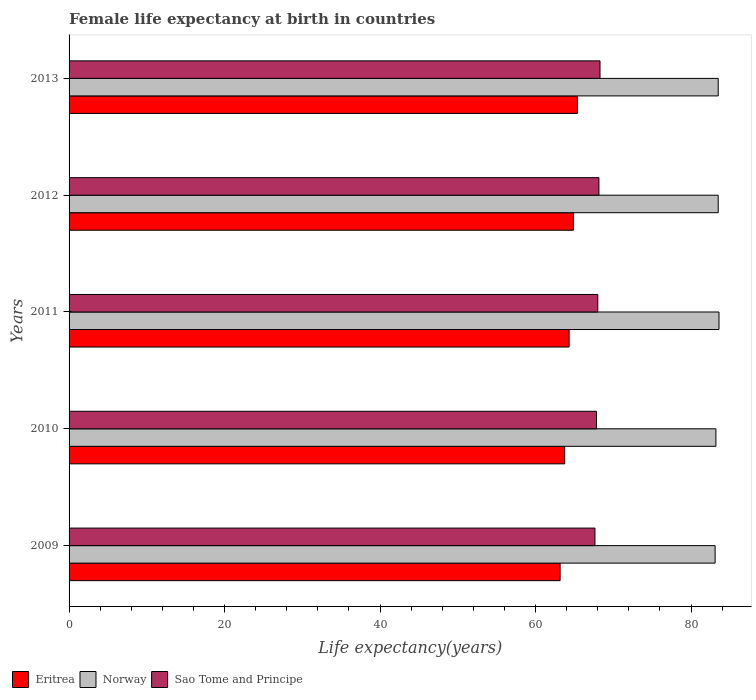How many groups of bars are there?
Offer a very short reply. 5. In how many cases, is the number of bars for a given year not equal to the number of legend labels?
Your response must be concise. 0. What is the female life expectancy at birth in Norway in 2012?
Give a very brief answer. 83.5. Across all years, what is the maximum female life expectancy at birth in Eritrea?
Offer a terse response. 65.39. Across all years, what is the minimum female life expectancy at birth in Sao Tome and Principe?
Your answer should be compact. 67.64. In which year was the female life expectancy at birth in Eritrea minimum?
Your answer should be very brief. 2009. What is the total female life expectancy at birth in Norway in the graph?
Give a very brief answer. 416.9. What is the difference between the female life expectancy at birth in Norway in 2009 and that in 2010?
Your answer should be very brief. -0.1. What is the difference between the female life expectancy at birth in Eritrea in 2011 and the female life expectancy at birth in Sao Tome and Principe in 2013?
Make the answer very short. -3.97. What is the average female life expectancy at birth in Eritrea per year?
Offer a very short reply. 64.3. In the year 2010, what is the difference between the female life expectancy at birth in Sao Tome and Principe and female life expectancy at birth in Norway?
Offer a terse response. -15.36. What is the ratio of the female life expectancy at birth in Norway in 2010 to that in 2012?
Provide a succinct answer. 1. Is the female life expectancy at birth in Eritrea in 2009 less than that in 2011?
Your response must be concise. Yes. Is the difference between the female life expectancy at birth in Sao Tome and Principe in 2010 and 2011 greater than the difference between the female life expectancy at birth in Norway in 2010 and 2011?
Give a very brief answer. Yes. What is the difference between the highest and the second highest female life expectancy at birth in Norway?
Provide a succinct answer. 0.1. What is the difference between the highest and the lowest female life expectancy at birth in Eritrea?
Offer a terse response. 2.23. Is the sum of the female life expectancy at birth in Sao Tome and Principe in 2011 and 2013 greater than the maximum female life expectancy at birth in Eritrea across all years?
Provide a succinct answer. Yes. What does the 3rd bar from the top in 2009 represents?
Provide a short and direct response. Eritrea. What does the 1st bar from the bottom in 2012 represents?
Ensure brevity in your answer.  Eritrea. Is it the case that in every year, the sum of the female life expectancy at birth in Norway and female life expectancy at birth in Sao Tome and Principe is greater than the female life expectancy at birth in Eritrea?
Provide a short and direct response. Yes. Are all the bars in the graph horizontal?
Offer a terse response. Yes. How many years are there in the graph?
Provide a succinct answer. 5. What is the difference between two consecutive major ticks on the X-axis?
Keep it short and to the point. 20. Where does the legend appear in the graph?
Offer a very short reply. Bottom left. How many legend labels are there?
Ensure brevity in your answer.  3. How are the legend labels stacked?
Provide a short and direct response. Horizontal. What is the title of the graph?
Provide a short and direct response. Female life expectancy at birth in countries. What is the label or title of the X-axis?
Keep it short and to the point. Life expectancy(years). What is the label or title of the Y-axis?
Provide a short and direct response. Years. What is the Life expectancy(years) in Eritrea in 2009?
Your response must be concise. 63.16. What is the Life expectancy(years) in Norway in 2009?
Your answer should be very brief. 83.1. What is the Life expectancy(years) in Sao Tome and Principe in 2009?
Your answer should be very brief. 67.64. What is the Life expectancy(years) in Eritrea in 2010?
Provide a short and direct response. 63.75. What is the Life expectancy(years) of Norway in 2010?
Give a very brief answer. 83.2. What is the Life expectancy(years) in Sao Tome and Principe in 2010?
Offer a terse response. 67.84. What is the Life expectancy(years) in Eritrea in 2011?
Your answer should be compact. 64.32. What is the Life expectancy(years) of Norway in 2011?
Your answer should be compact. 83.6. What is the Life expectancy(years) in Sao Tome and Principe in 2011?
Offer a very short reply. 68.01. What is the Life expectancy(years) of Eritrea in 2012?
Make the answer very short. 64.87. What is the Life expectancy(years) of Norway in 2012?
Provide a short and direct response. 83.5. What is the Life expectancy(years) of Sao Tome and Principe in 2012?
Offer a very short reply. 68.15. What is the Life expectancy(years) of Eritrea in 2013?
Make the answer very short. 65.39. What is the Life expectancy(years) in Norway in 2013?
Ensure brevity in your answer.  83.5. What is the Life expectancy(years) in Sao Tome and Principe in 2013?
Keep it short and to the point. 68.3. Across all years, what is the maximum Life expectancy(years) of Eritrea?
Your answer should be very brief. 65.39. Across all years, what is the maximum Life expectancy(years) in Norway?
Your answer should be very brief. 83.6. Across all years, what is the maximum Life expectancy(years) of Sao Tome and Principe?
Your response must be concise. 68.3. Across all years, what is the minimum Life expectancy(years) of Eritrea?
Provide a short and direct response. 63.16. Across all years, what is the minimum Life expectancy(years) in Norway?
Provide a succinct answer. 83.1. Across all years, what is the minimum Life expectancy(years) of Sao Tome and Principe?
Your answer should be compact. 67.64. What is the total Life expectancy(years) in Eritrea in the graph?
Your answer should be very brief. 321.49. What is the total Life expectancy(years) of Norway in the graph?
Keep it short and to the point. 416.9. What is the total Life expectancy(years) of Sao Tome and Principe in the graph?
Make the answer very short. 339.94. What is the difference between the Life expectancy(years) in Eritrea in 2009 and that in 2010?
Provide a short and direct response. -0.59. What is the difference between the Life expectancy(years) of Eritrea in 2009 and that in 2011?
Your answer should be compact. -1.16. What is the difference between the Life expectancy(years) of Sao Tome and Principe in 2009 and that in 2011?
Ensure brevity in your answer.  -0.37. What is the difference between the Life expectancy(years) of Eritrea in 2009 and that in 2012?
Offer a very short reply. -1.71. What is the difference between the Life expectancy(years) of Sao Tome and Principe in 2009 and that in 2012?
Offer a very short reply. -0.51. What is the difference between the Life expectancy(years) in Eritrea in 2009 and that in 2013?
Your answer should be very brief. -2.23. What is the difference between the Life expectancy(years) of Norway in 2009 and that in 2013?
Your answer should be compact. -0.4. What is the difference between the Life expectancy(years) in Sao Tome and Principe in 2009 and that in 2013?
Your answer should be compact. -0.65. What is the difference between the Life expectancy(years) of Eritrea in 2010 and that in 2011?
Offer a terse response. -0.57. What is the difference between the Life expectancy(years) of Norway in 2010 and that in 2011?
Make the answer very short. -0.4. What is the difference between the Life expectancy(years) in Sao Tome and Principe in 2010 and that in 2011?
Ensure brevity in your answer.  -0.17. What is the difference between the Life expectancy(years) of Eritrea in 2010 and that in 2012?
Your answer should be very brief. -1.12. What is the difference between the Life expectancy(years) of Norway in 2010 and that in 2012?
Your answer should be compact. -0.3. What is the difference between the Life expectancy(years) of Sao Tome and Principe in 2010 and that in 2012?
Your response must be concise. -0.31. What is the difference between the Life expectancy(years) in Eritrea in 2010 and that in 2013?
Offer a terse response. -1.64. What is the difference between the Life expectancy(years) of Norway in 2010 and that in 2013?
Your answer should be compact. -0.3. What is the difference between the Life expectancy(years) of Sao Tome and Principe in 2010 and that in 2013?
Your answer should be compact. -0.45. What is the difference between the Life expectancy(years) of Eritrea in 2011 and that in 2012?
Keep it short and to the point. -0.55. What is the difference between the Life expectancy(years) in Sao Tome and Principe in 2011 and that in 2012?
Offer a very short reply. -0.15. What is the difference between the Life expectancy(years) of Eritrea in 2011 and that in 2013?
Provide a short and direct response. -1.07. What is the difference between the Life expectancy(years) of Norway in 2011 and that in 2013?
Your answer should be compact. 0.1. What is the difference between the Life expectancy(years) of Sao Tome and Principe in 2011 and that in 2013?
Keep it short and to the point. -0.29. What is the difference between the Life expectancy(years) in Eritrea in 2012 and that in 2013?
Your answer should be compact. -0.52. What is the difference between the Life expectancy(years) of Sao Tome and Principe in 2012 and that in 2013?
Your answer should be compact. -0.14. What is the difference between the Life expectancy(years) in Eritrea in 2009 and the Life expectancy(years) in Norway in 2010?
Make the answer very short. -20.04. What is the difference between the Life expectancy(years) in Eritrea in 2009 and the Life expectancy(years) in Sao Tome and Principe in 2010?
Offer a very short reply. -4.68. What is the difference between the Life expectancy(years) of Norway in 2009 and the Life expectancy(years) of Sao Tome and Principe in 2010?
Give a very brief answer. 15.26. What is the difference between the Life expectancy(years) of Eritrea in 2009 and the Life expectancy(years) of Norway in 2011?
Provide a short and direct response. -20.44. What is the difference between the Life expectancy(years) in Eritrea in 2009 and the Life expectancy(years) in Sao Tome and Principe in 2011?
Provide a short and direct response. -4.84. What is the difference between the Life expectancy(years) of Norway in 2009 and the Life expectancy(years) of Sao Tome and Principe in 2011?
Your answer should be compact. 15.09. What is the difference between the Life expectancy(years) in Eritrea in 2009 and the Life expectancy(years) in Norway in 2012?
Your response must be concise. -20.34. What is the difference between the Life expectancy(years) of Eritrea in 2009 and the Life expectancy(years) of Sao Tome and Principe in 2012?
Offer a terse response. -4.99. What is the difference between the Life expectancy(years) in Norway in 2009 and the Life expectancy(years) in Sao Tome and Principe in 2012?
Offer a very short reply. 14.95. What is the difference between the Life expectancy(years) of Eritrea in 2009 and the Life expectancy(years) of Norway in 2013?
Your answer should be compact. -20.34. What is the difference between the Life expectancy(years) of Eritrea in 2009 and the Life expectancy(years) of Sao Tome and Principe in 2013?
Your answer should be compact. -5.13. What is the difference between the Life expectancy(years) of Norway in 2009 and the Life expectancy(years) of Sao Tome and Principe in 2013?
Provide a short and direct response. 14.8. What is the difference between the Life expectancy(years) in Eritrea in 2010 and the Life expectancy(years) in Norway in 2011?
Provide a short and direct response. -19.85. What is the difference between the Life expectancy(years) of Eritrea in 2010 and the Life expectancy(years) of Sao Tome and Principe in 2011?
Your answer should be very brief. -4.26. What is the difference between the Life expectancy(years) of Norway in 2010 and the Life expectancy(years) of Sao Tome and Principe in 2011?
Your answer should be very brief. 15.19. What is the difference between the Life expectancy(years) of Eritrea in 2010 and the Life expectancy(years) of Norway in 2012?
Provide a short and direct response. -19.75. What is the difference between the Life expectancy(years) of Eritrea in 2010 and the Life expectancy(years) of Sao Tome and Principe in 2012?
Provide a short and direct response. -4.41. What is the difference between the Life expectancy(years) of Norway in 2010 and the Life expectancy(years) of Sao Tome and Principe in 2012?
Your response must be concise. 15.05. What is the difference between the Life expectancy(years) of Eritrea in 2010 and the Life expectancy(years) of Norway in 2013?
Your answer should be compact. -19.75. What is the difference between the Life expectancy(years) of Eritrea in 2010 and the Life expectancy(years) of Sao Tome and Principe in 2013?
Keep it short and to the point. -4.55. What is the difference between the Life expectancy(years) in Norway in 2010 and the Life expectancy(years) in Sao Tome and Principe in 2013?
Ensure brevity in your answer.  14.9. What is the difference between the Life expectancy(years) of Eritrea in 2011 and the Life expectancy(years) of Norway in 2012?
Your response must be concise. -19.18. What is the difference between the Life expectancy(years) in Eritrea in 2011 and the Life expectancy(years) in Sao Tome and Principe in 2012?
Give a very brief answer. -3.83. What is the difference between the Life expectancy(years) in Norway in 2011 and the Life expectancy(years) in Sao Tome and Principe in 2012?
Your response must be concise. 15.45. What is the difference between the Life expectancy(years) of Eritrea in 2011 and the Life expectancy(years) of Norway in 2013?
Offer a terse response. -19.18. What is the difference between the Life expectancy(years) in Eritrea in 2011 and the Life expectancy(years) in Sao Tome and Principe in 2013?
Give a very brief answer. -3.97. What is the difference between the Life expectancy(years) of Norway in 2011 and the Life expectancy(years) of Sao Tome and Principe in 2013?
Provide a short and direct response. 15.3. What is the difference between the Life expectancy(years) of Eritrea in 2012 and the Life expectancy(years) of Norway in 2013?
Make the answer very short. -18.63. What is the difference between the Life expectancy(years) in Eritrea in 2012 and the Life expectancy(years) in Sao Tome and Principe in 2013?
Make the answer very short. -3.42. What is the difference between the Life expectancy(years) of Norway in 2012 and the Life expectancy(years) of Sao Tome and Principe in 2013?
Keep it short and to the point. 15.2. What is the average Life expectancy(years) of Eritrea per year?
Provide a succinct answer. 64.3. What is the average Life expectancy(years) in Norway per year?
Your answer should be compact. 83.38. What is the average Life expectancy(years) in Sao Tome and Principe per year?
Give a very brief answer. 67.99. In the year 2009, what is the difference between the Life expectancy(years) of Eritrea and Life expectancy(years) of Norway?
Offer a very short reply. -19.94. In the year 2009, what is the difference between the Life expectancy(years) of Eritrea and Life expectancy(years) of Sao Tome and Principe?
Your response must be concise. -4.48. In the year 2009, what is the difference between the Life expectancy(years) in Norway and Life expectancy(years) in Sao Tome and Principe?
Your response must be concise. 15.46. In the year 2010, what is the difference between the Life expectancy(years) of Eritrea and Life expectancy(years) of Norway?
Provide a succinct answer. -19.45. In the year 2010, what is the difference between the Life expectancy(years) in Eritrea and Life expectancy(years) in Sao Tome and Principe?
Provide a short and direct response. -4.09. In the year 2010, what is the difference between the Life expectancy(years) of Norway and Life expectancy(years) of Sao Tome and Principe?
Provide a short and direct response. 15.36. In the year 2011, what is the difference between the Life expectancy(years) of Eritrea and Life expectancy(years) of Norway?
Offer a very short reply. -19.28. In the year 2011, what is the difference between the Life expectancy(years) in Eritrea and Life expectancy(years) in Sao Tome and Principe?
Keep it short and to the point. -3.69. In the year 2011, what is the difference between the Life expectancy(years) in Norway and Life expectancy(years) in Sao Tome and Principe?
Provide a short and direct response. 15.59. In the year 2012, what is the difference between the Life expectancy(years) in Eritrea and Life expectancy(years) in Norway?
Make the answer very short. -18.63. In the year 2012, what is the difference between the Life expectancy(years) of Eritrea and Life expectancy(years) of Sao Tome and Principe?
Provide a succinct answer. -3.28. In the year 2012, what is the difference between the Life expectancy(years) of Norway and Life expectancy(years) of Sao Tome and Principe?
Your response must be concise. 15.35. In the year 2013, what is the difference between the Life expectancy(years) in Eritrea and Life expectancy(years) in Norway?
Make the answer very short. -18.11. In the year 2013, what is the difference between the Life expectancy(years) in Eritrea and Life expectancy(years) in Sao Tome and Principe?
Your answer should be compact. -2.91. In the year 2013, what is the difference between the Life expectancy(years) of Norway and Life expectancy(years) of Sao Tome and Principe?
Offer a very short reply. 15.2. What is the ratio of the Life expectancy(years) in Eritrea in 2009 to that in 2010?
Offer a terse response. 0.99. What is the ratio of the Life expectancy(years) of Norway in 2009 to that in 2010?
Keep it short and to the point. 1. What is the ratio of the Life expectancy(years) of Eritrea in 2009 to that in 2011?
Ensure brevity in your answer.  0.98. What is the ratio of the Life expectancy(years) in Norway in 2009 to that in 2011?
Give a very brief answer. 0.99. What is the ratio of the Life expectancy(years) of Eritrea in 2009 to that in 2012?
Your answer should be compact. 0.97. What is the ratio of the Life expectancy(years) of Norway in 2009 to that in 2012?
Your answer should be very brief. 1. What is the ratio of the Life expectancy(years) of Eritrea in 2009 to that in 2013?
Make the answer very short. 0.97. What is the ratio of the Life expectancy(years) in Sao Tome and Principe in 2009 to that in 2013?
Keep it short and to the point. 0.99. What is the ratio of the Life expectancy(years) of Eritrea in 2010 to that in 2011?
Offer a terse response. 0.99. What is the ratio of the Life expectancy(years) of Eritrea in 2010 to that in 2012?
Your answer should be compact. 0.98. What is the ratio of the Life expectancy(years) in Eritrea in 2010 to that in 2013?
Ensure brevity in your answer.  0.97. What is the ratio of the Life expectancy(years) of Sao Tome and Principe in 2010 to that in 2013?
Provide a succinct answer. 0.99. What is the ratio of the Life expectancy(years) in Eritrea in 2011 to that in 2012?
Give a very brief answer. 0.99. What is the ratio of the Life expectancy(years) of Norway in 2011 to that in 2012?
Your response must be concise. 1. What is the ratio of the Life expectancy(years) in Sao Tome and Principe in 2011 to that in 2012?
Ensure brevity in your answer.  1. What is the ratio of the Life expectancy(years) in Eritrea in 2011 to that in 2013?
Provide a succinct answer. 0.98. What is the ratio of the Life expectancy(years) of Norway in 2012 to that in 2013?
Your response must be concise. 1. What is the difference between the highest and the second highest Life expectancy(years) in Eritrea?
Ensure brevity in your answer.  0.52. What is the difference between the highest and the second highest Life expectancy(years) in Sao Tome and Principe?
Your answer should be compact. 0.14. What is the difference between the highest and the lowest Life expectancy(years) in Eritrea?
Offer a very short reply. 2.23. What is the difference between the highest and the lowest Life expectancy(years) in Norway?
Provide a succinct answer. 0.5. What is the difference between the highest and the lowest Life expectancy(years) in Sao Tome and Principe?
Your answer should be compact. 0.65. 